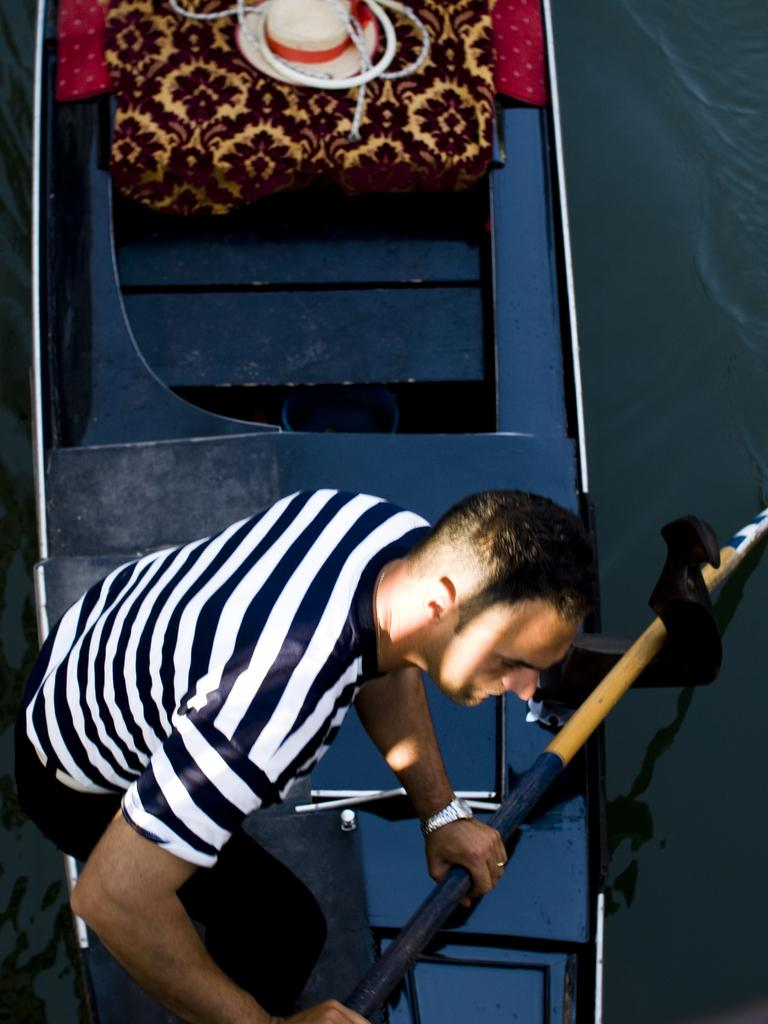What is the main subject of the image? There is a person standing in the center of the image. What is the person holding in the image? The person is holding an object. What can be seen in the background of the image? There is a wall, a bag, a hat, cloth, and a few other objects in the background of the image. What is the income of the person in the image? There is no information about the person's income in the image. Does the existence of the hat in the image prove the existence of a hat-making industry in the area? The presence of a hat in the image does not provide any information about the existence of a hat-making industry in the area. 